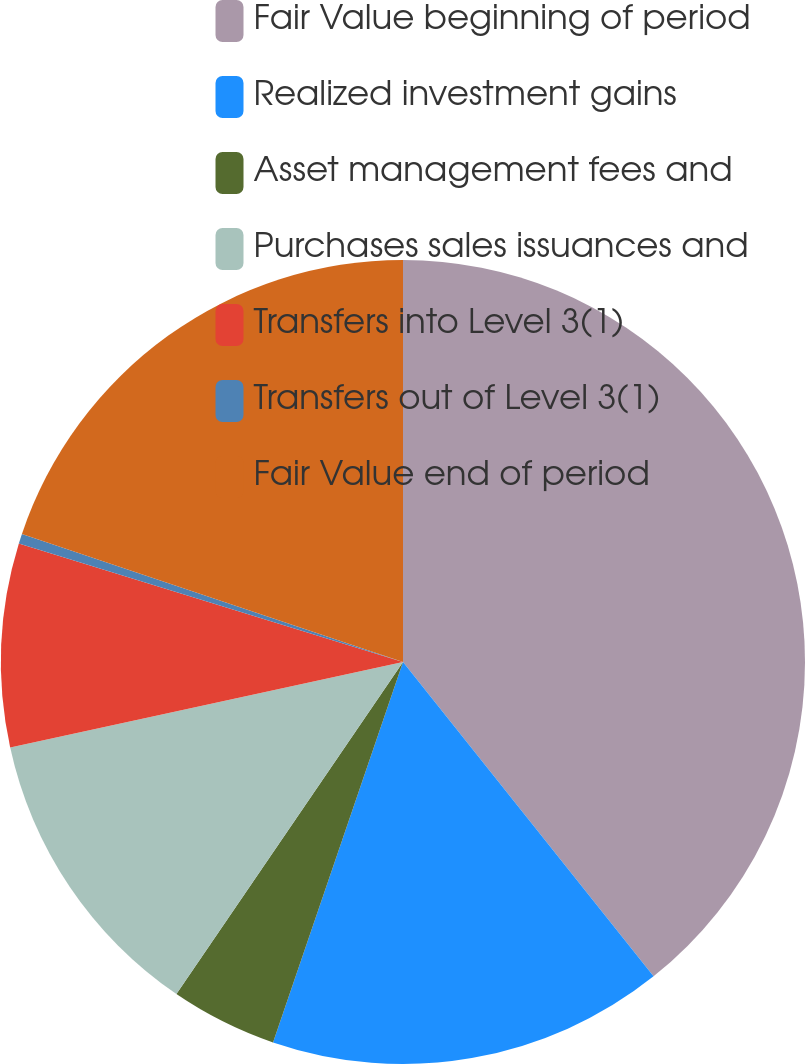<chart> <loc_0><loc_0><loc_500><loc_500><pie_chart><fcel>Fair Value beginning of period<fcel>Realized investment gains<fcel>Asset management fees and<fcel>Purchases sales issuances and<fcel>Transfers into Level 3(1)<fcel>Transfers out of Level 3(1)<fcel>Fair Value end of period<nl><fcel>39.29%<fcel>15.95%<fcel>4.29%<fcel>12.06%<fcel>8.17%<fcel>0.4%<fcel>19.84%<nl></chart> 